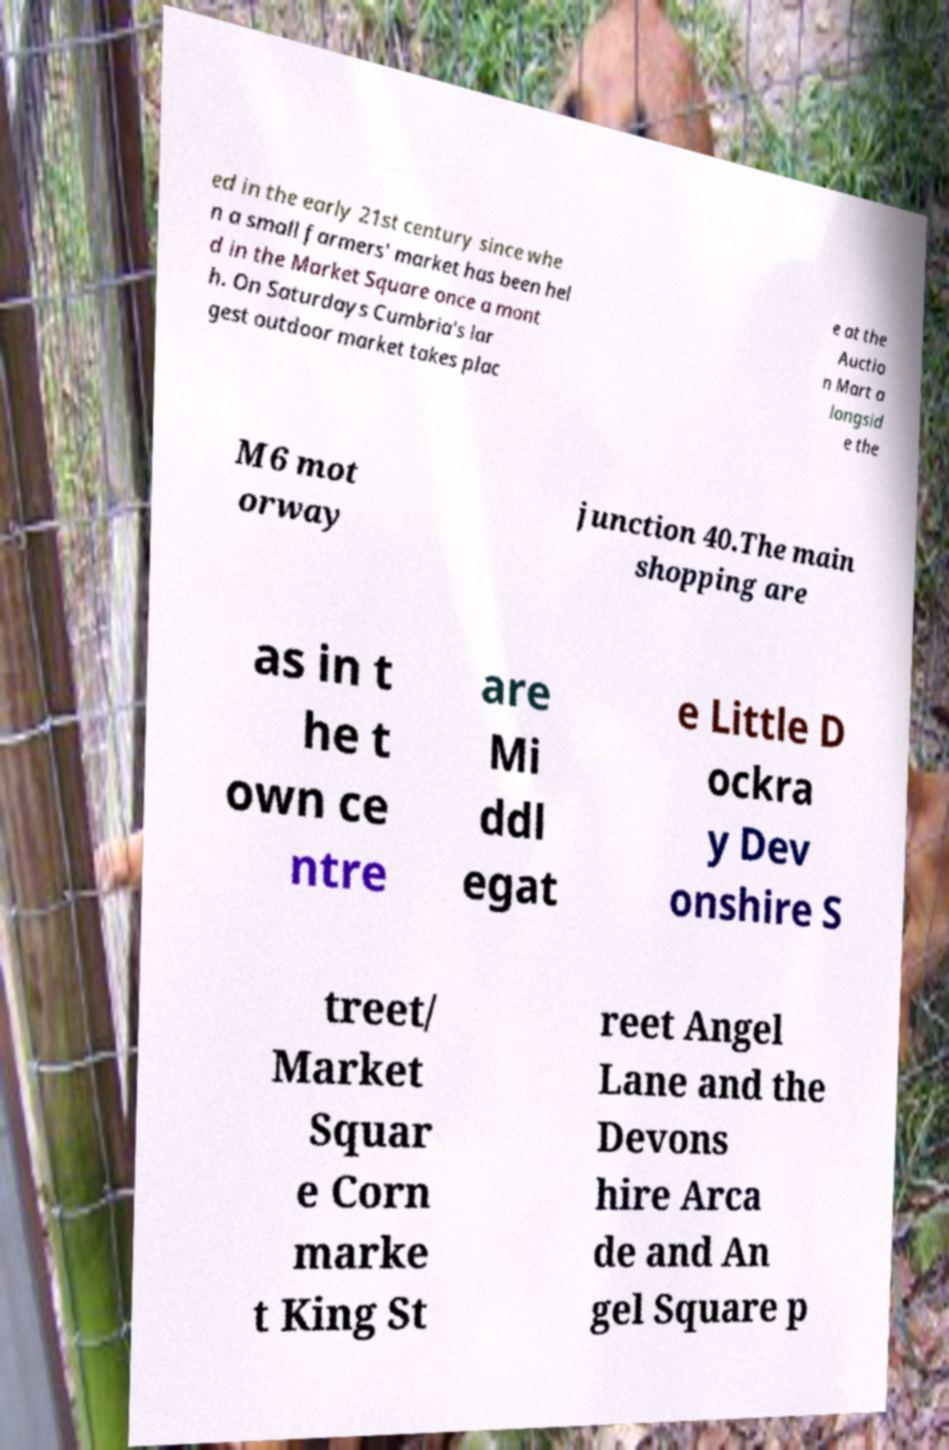Can you read and provide the text displayed in the image?This photo seems to have some interesting text. Can you extract and type it out for me? ed in the early 21st century since whe n a small farmers' market has been hel d in the Market Square once a mont h. On Saturdays Cumbria's lar gest outdoor market takes plac e at the Auctio n Mart a longsid e the M6 mot orway junction 40.The main shopping are as in t he t own ce ntre are Mi ddl egat e Little D ockra y Dev onshire S treet/ Market Squar e Corn marke t King St reet Angel Lane and the Devons hire Arca de and An gel Square p 